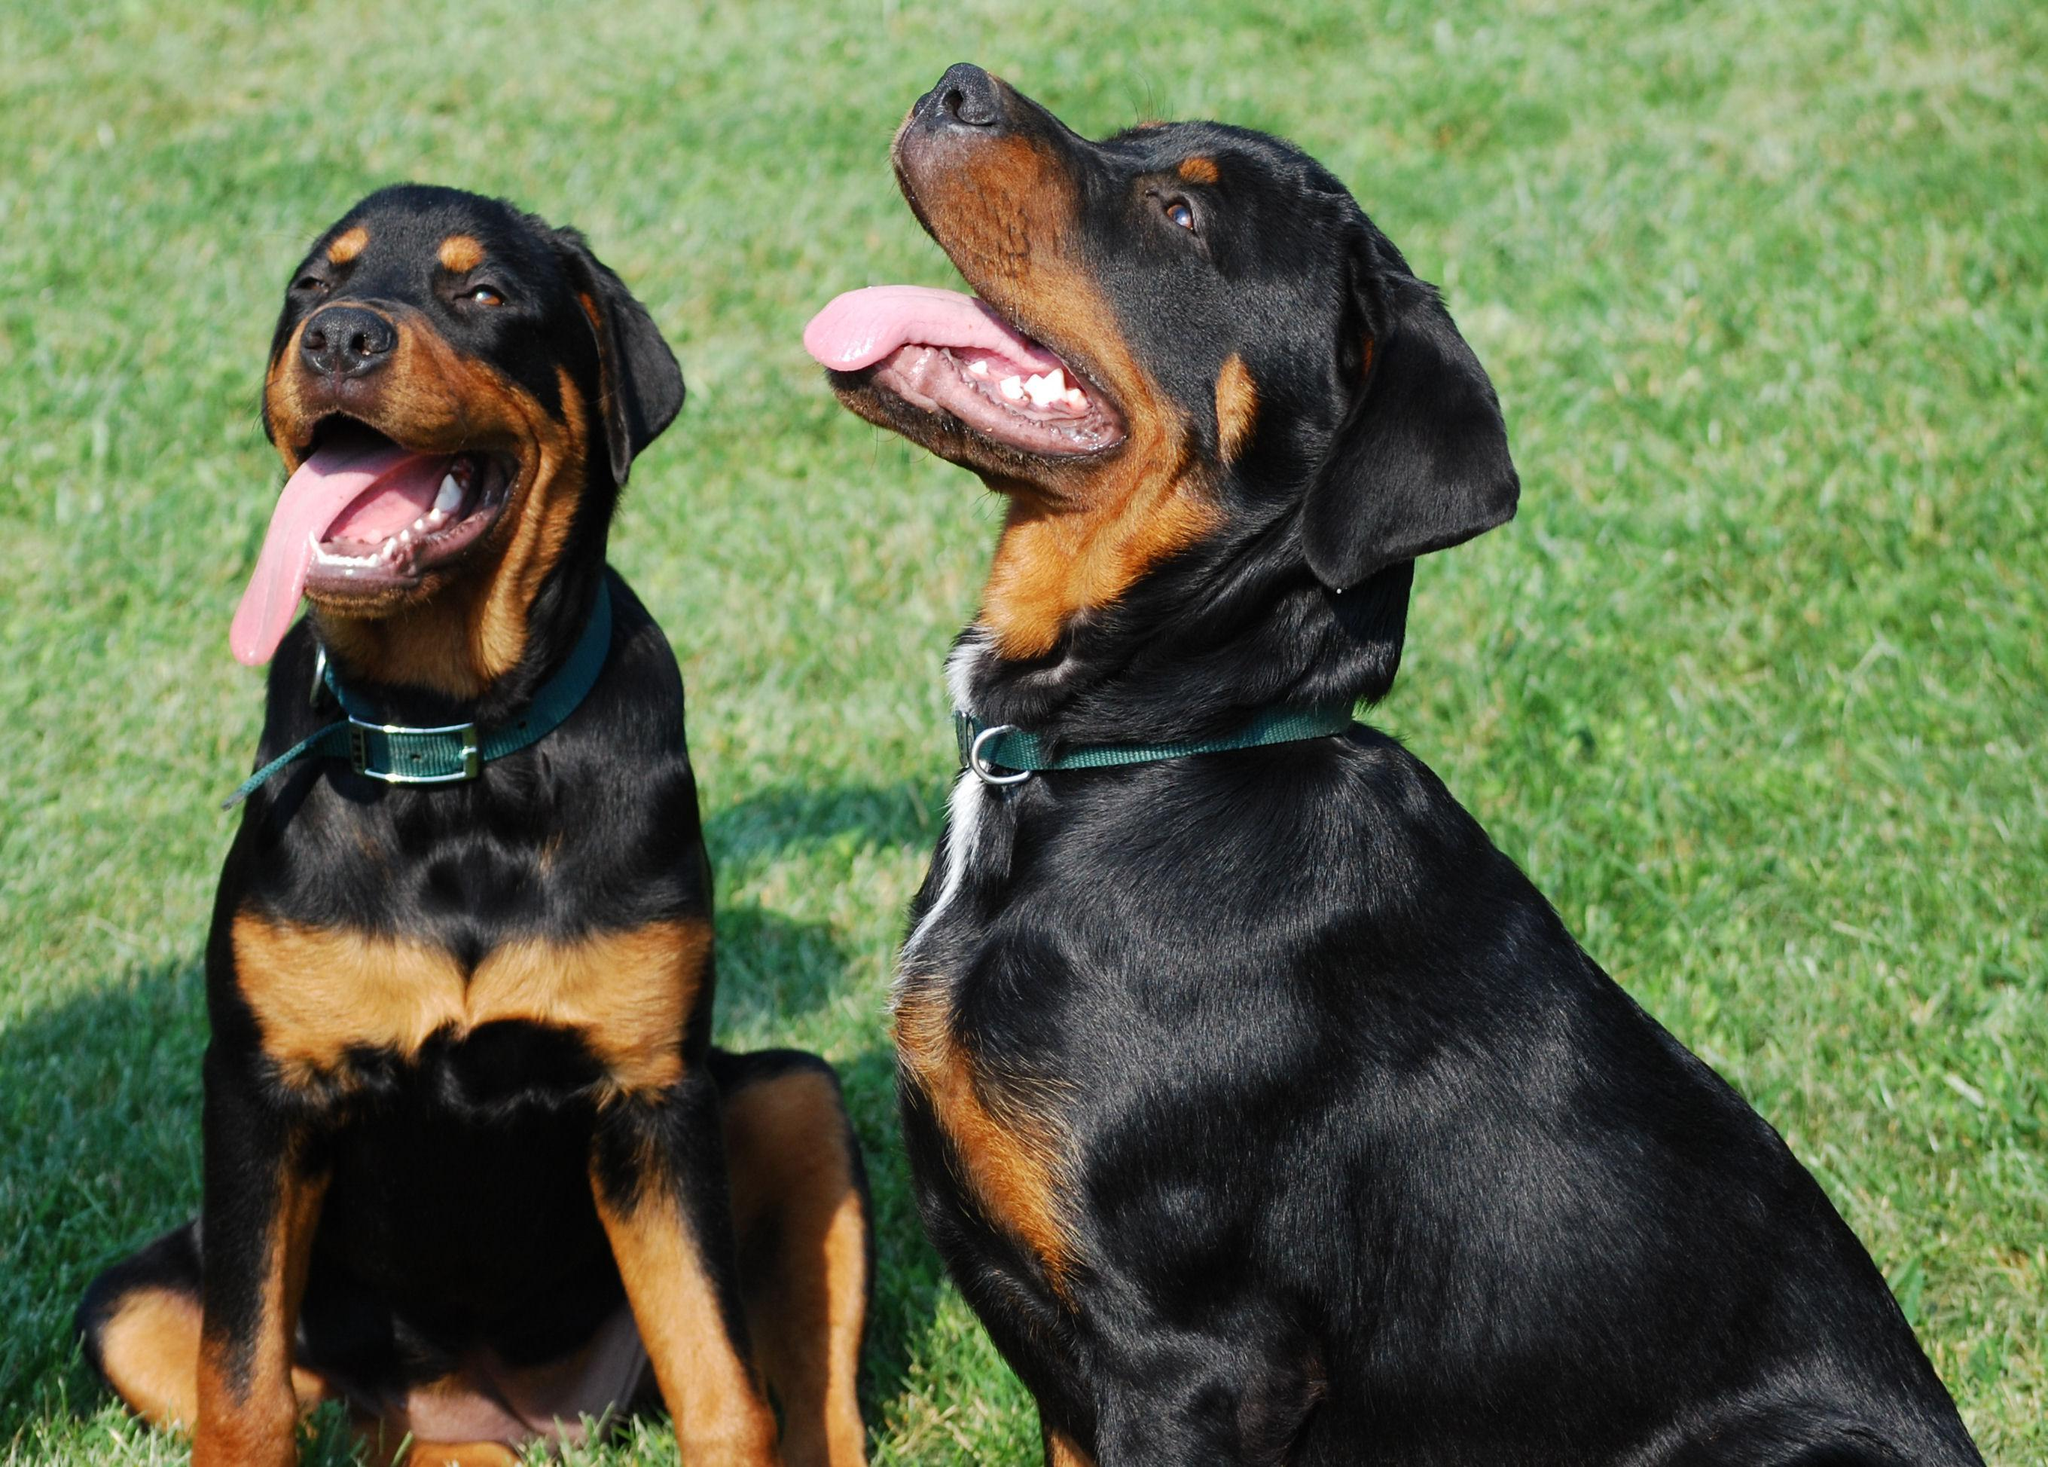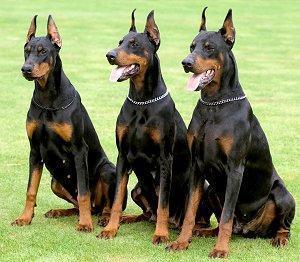The first image is the image on the left, the second image is the image on the right. Analyze the images presented: Is the assertion "The right image contains no more than three dogs." valid? Answer yes or no. Yes. The first image is the image on the left, the second image is the image on the right. Given the left and right images, does the statement "The left image contains one rightward-gazing doberman with erect ears, and the right image features a reclining doberman accompanied by at least three other dogs." hold true? Answer yes or no. No. 